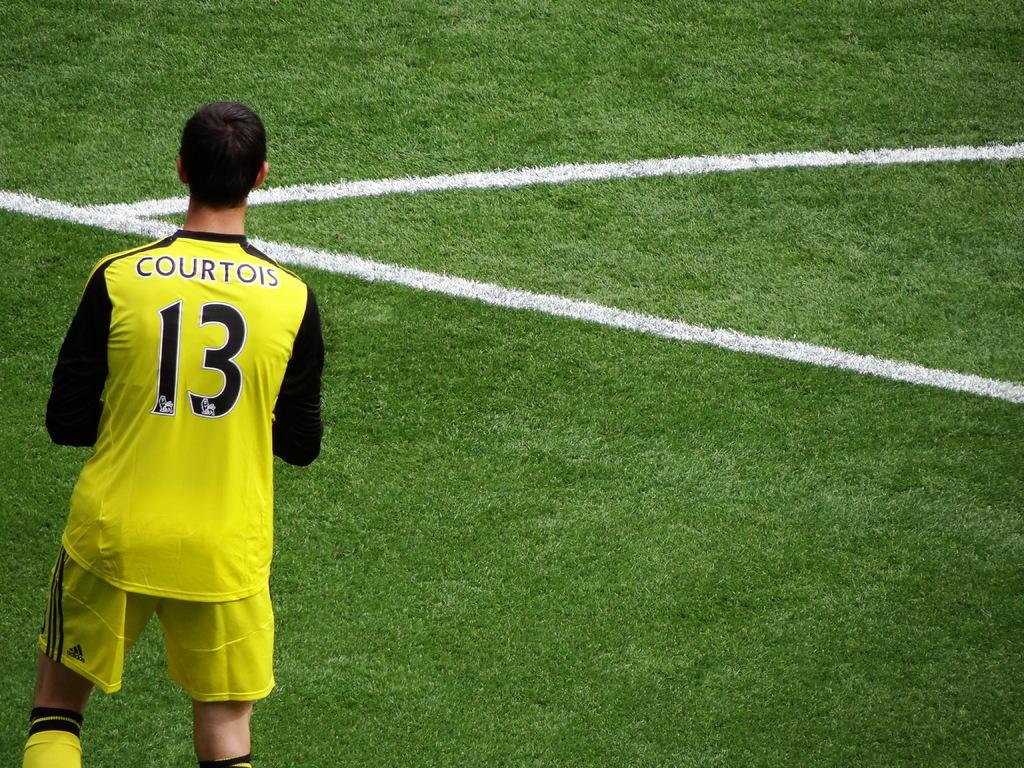<image>
Describe the image concisely. a person with the number 13 on their soccer jersey 